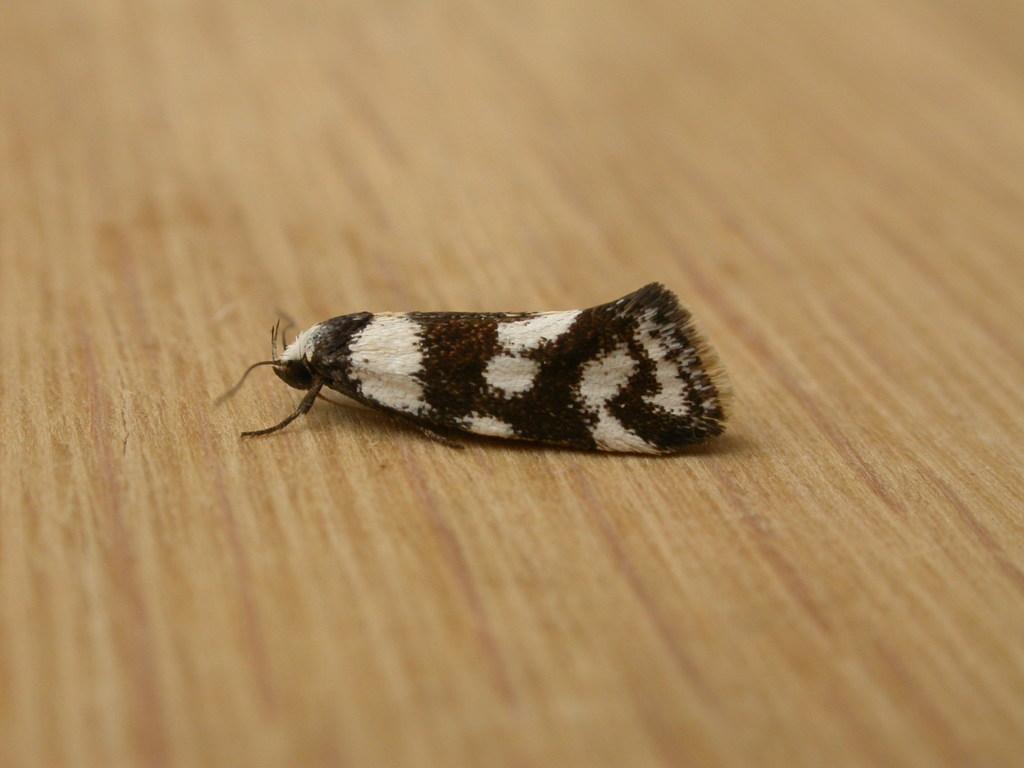How would you summarize this image in a sentence or two? In this picture we can see an insect on a wooden platform. 